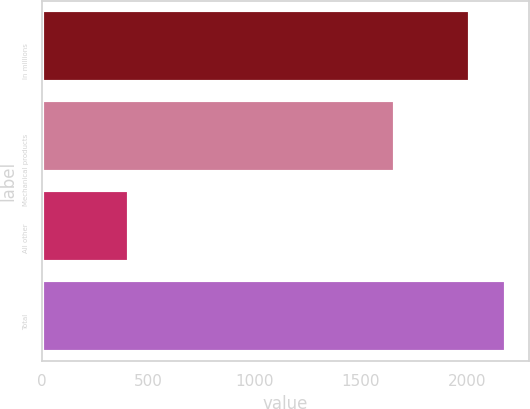Convert chart to OTSL. <chart><loc_0><loc_0><loc_500><loc_500><bar_chart><fcel>In millions<fcel>Mechanical products<fcel>All other<fcel>Total<nl><fcel>2015<fcel>1661.4<fcel>406.7<fcel>2181.14<nl></chart> 